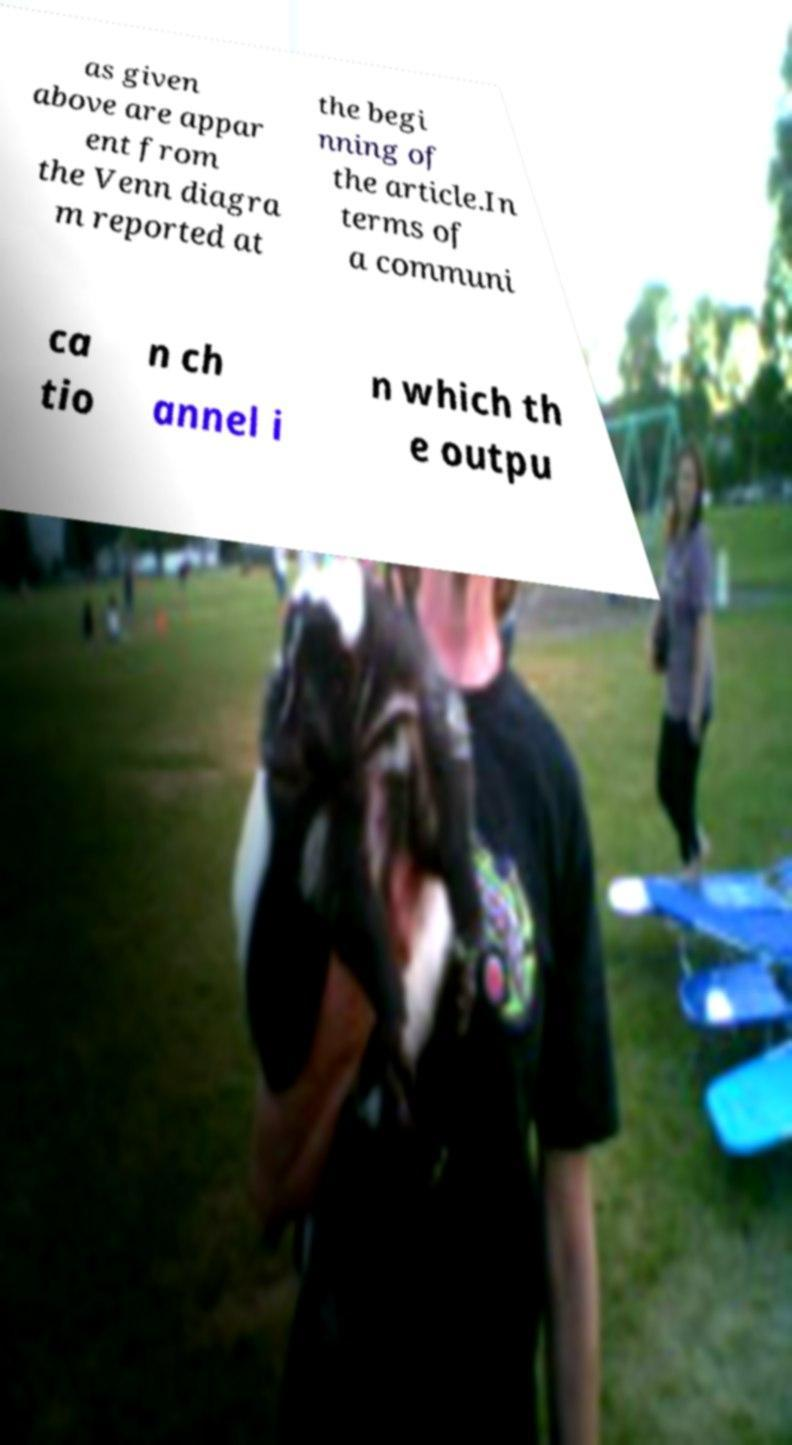There's text embedded in this image that I need extracted. Can you transcribe it verbatim? as given above are appar ent from the Venn diagra m reported at the begi nning of the article.In terms of a communi ca tio n ch annel i n which th e outpu 